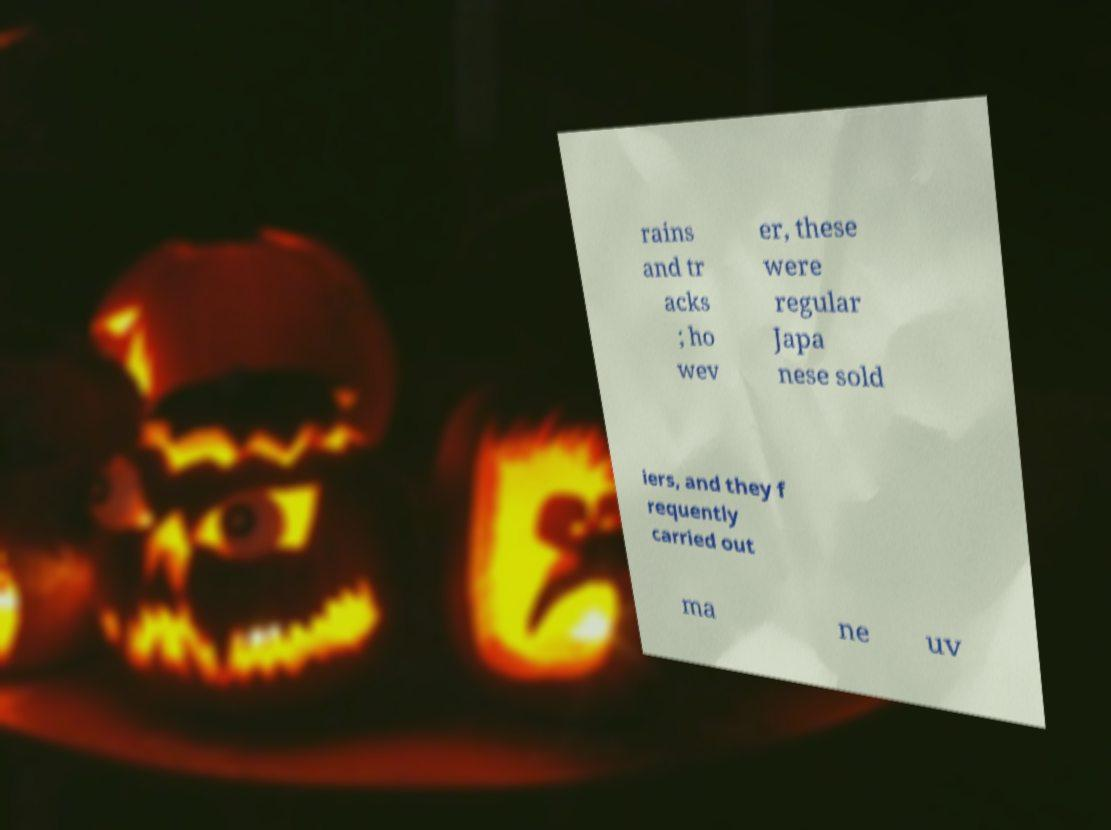Can you accurately transcribe the text from the provided image for me? rains and tr acks ; ho wev er, these were regular Japa nese sold iers, and they f requently carried out ma ne uv 